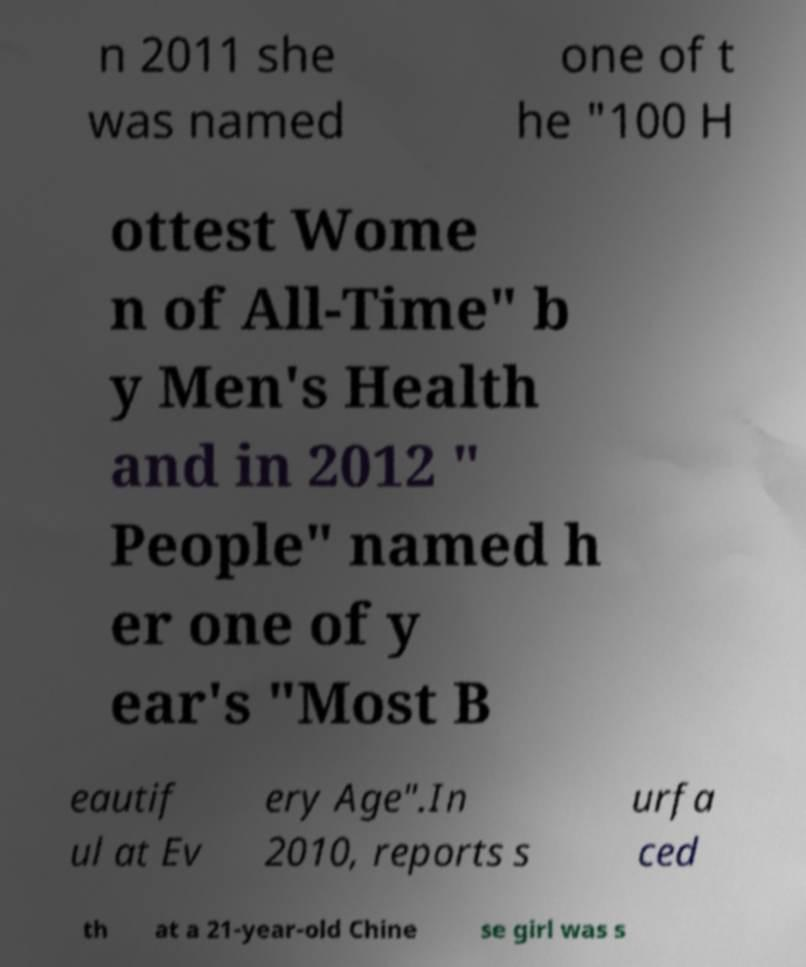Can you accurately transcribe the text from the provided image for me? n 2011 she was named one of t he "100 H ottest Wome n of All-Time" b y Men's Health and in 2012 " People" named h er one of y ear's "Most B eautif ul at Ev ery Age".In 2010, reports s urfa ced th at a 21-year-old Chine se girl was s 